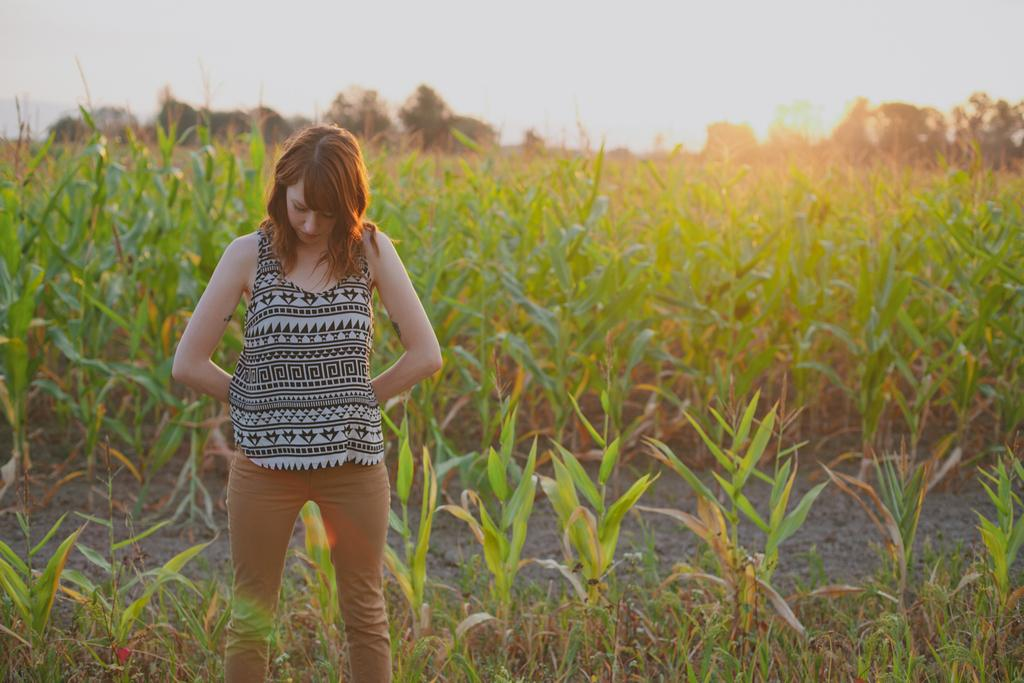Who is the main subject in the image? There is a girl standing in the image. What can be seen in the background of the image? There are green plants in a farm visible in the background. What is visible at the top of the image? The sky is visible at the top of the image. Where is the lake located in the image? There is no lake present in the image. What type of garden can be seen in the image? There is no garden present in the image; it features a girl standing in front of green plants in a farm. 